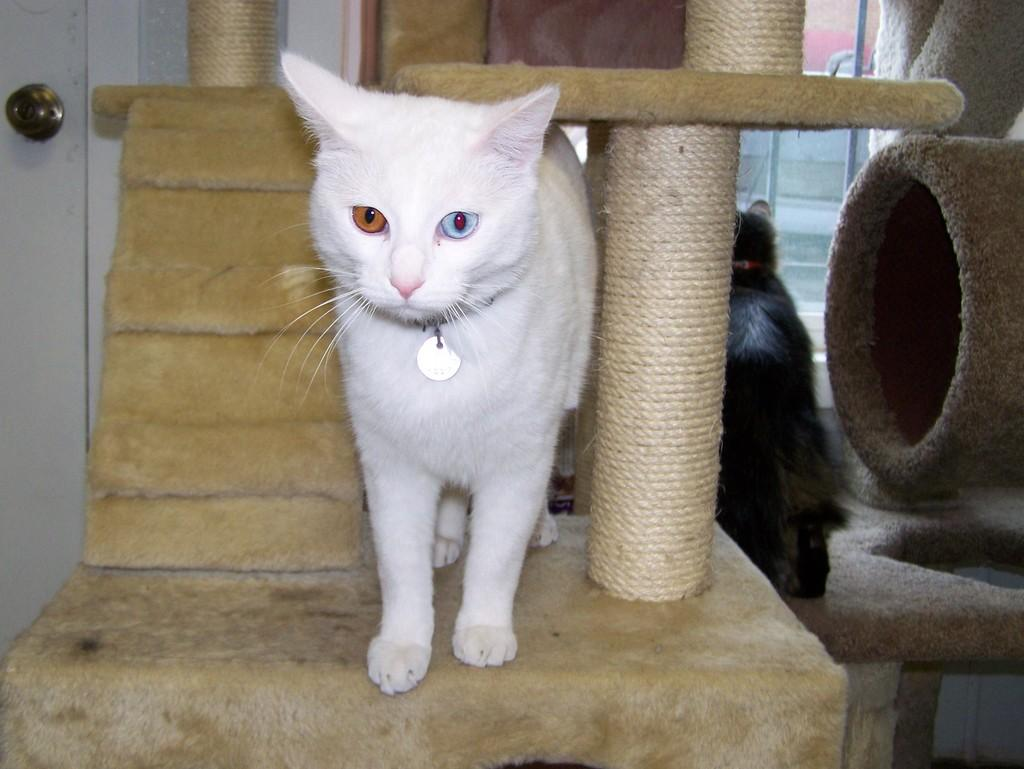What type of animal is in the image? There is a white cat in the image. What is the cat doing in the image? The cat is standing on an object. Is there another animal in the image besides the cat? Yes, there is an animal beside the cat. What can be seen in front of the animal? There is a window in front of the animal. What type of shoe is the cat wearing in the image? The cat is not wearing a shoe in the image; it is a cat and does not wear shoes. 